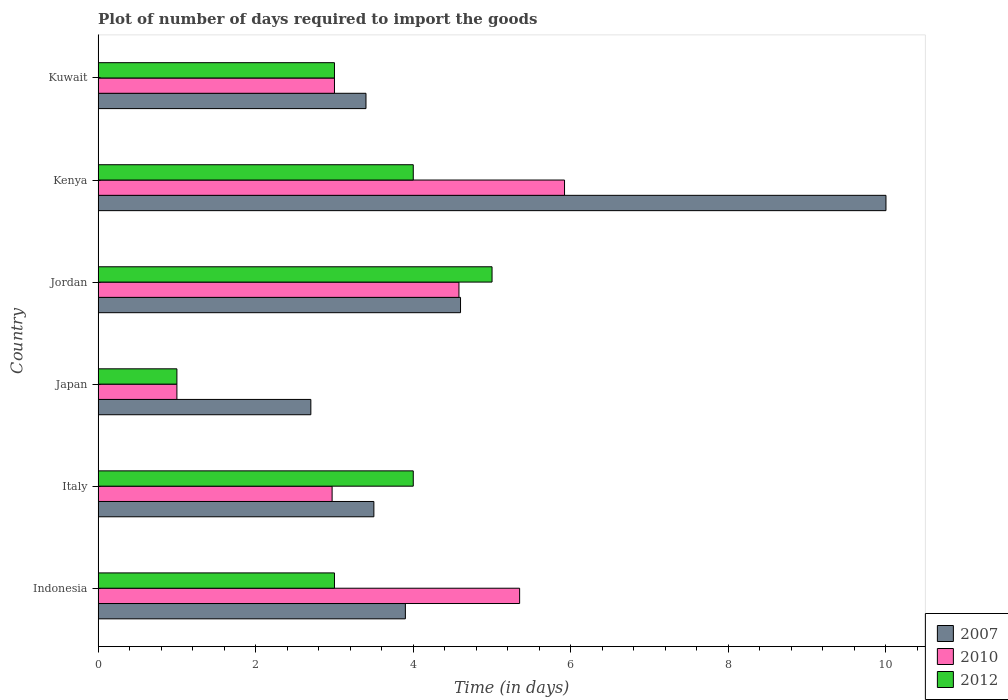Are the number of bars on each tick of the Y-axis equal?
Your answer should be compact. Yes. How many bars are there on the 1st tick from the top?
Keep it short and to the point. 3. How many bars are there on the 3rd tick from the bottom?
Provide a succinct answer. 3. In how many cases, is the number of bars for a given country not equal to the number of legend labels?
Your answer should be compact. 0. What is the time required to import goods in 2007 in Kenya?
Ensure brevity in your answer.  10. In which country was the time required to import goods in 2007 maximum?
Provide a succinct answer. Kenya. What is the total time required to import goods in 2010 in the graph?
Provide a succinct answer. 22.82. What is the difference between the time required to import goods in 2010 in Japan and that in Jordan?
Provide a succinct answer. -3.58. What is the difference between the time required to import goods in 2012 in Jordan and the time required to import goods in 2010 in Kuwait?
Make the answer very short. 2. What is the average time required to import goods in 2012 per country?
Provide a succinct answer. 3.33. What is the difference between the time required to import goods in 2010 and time required to import goods in 2007 in Jordan?
Offer a terse response. -0.02. In how many countries, is the time required to import goods in 2010 greater than 1.6 days?
Your answer should be very brief. 5. What is the ratio of the time required to import goods in 2007 in Indonesia to that in Japan?
Give a very brief answer. 1.44. Is the difference between the time required to import goods in 2010 in Italy and Jordan greater than the difference between the time required to import goods in 2007 in Italy and Jordan?
Ensure brevity in your answer.  No. What is the difference between the highest and the second highest time required to import goods in 2010?
Make the answer very short. 0.57. What is the difference between the highest and the lowest time required to import goods in 2010?
Keep it short and to the point. 4.92. Is the sum of the time required to import goods in 2010 in Italy and Kenya greater than the maximum time required to import goods in 2012 across all countries?
Keep it short and to the point. Yes. Is it the case that in every country, the sum of the time required to import goods in 2010 and time required to import goods in 2007 is greater than the time required to import goods in 2012?
Provide a short and direct response. Yes. How many bars are there?
Your answer should be compact. 18. Are all the bars in the graph horizontal?
Provide a short and direct response. Yes. How are the legend labels stacked?
Make the answer very short. Vertical. What is the title of the graph?
Provide a short and direct response. Plot of number of days required to import the goods. Does "1993" appear as one of the legend labels in the graph?
Provide a short and direct response. No. What is the label or title of the X-axis?
Your response must be concise. Time (in days). What is the label or title of the Y-axis?
Provide a short and direct response. Country. What is the Time (in days) in 2007 in Indonesia?
Your answer should be very brief. 3.9. What is the Time (in days) of 2010 in Indonesia?
Your answer should be compact. 5.35. What is the Time (in days) in 2012 in Indonesia?
Your answer should be compact. 3. What is the Time (in days) of 2007 in Italy?
Offer a terse response. 3.5. What is the Time (in days) of 2010 in Italy?
Your response must be concise. 2.97. What is the Time (in days) of 2007 in Japan?
Your answer should be very brief. 2.7. What is the Time (in days) of 2012 in Japan?
Offer a very short reply. 1. What is the Time (in days) of 2010 in Jordan?
Your answer should be very brief. 4.58. What is the Time (in days) of 2012 in Jordan?
Provide a succinct answer. 5. What is the Time (in days) of 2010 in Kenya?
Provide a short and direct response. 5.92. What is the Time (in days) in 2012 in Kenya?
Provide a succinct answer. 4. What is the Time (in days) in 2007 in Kuwait?
Make the answer very short. 3.4. What is the Time (in days) in 2010 in Kuwait?
Provide a succinct answer. 3. What is the Time (in days) in 2012 in Kuwait?
Offer a very short reply. 3. Across all countries, what is the maximum Time (in days) in 2007?
Offer a terse response. 10. Across all countries, what is the maximum Time (in days) in 2010?
Provide a short and direct response. 5.92. Across all countries, what is the minimum Time (in days) of 2007?
Your response must be concise. 2.7. Across all countries, what is the minimum Time (in days) in 2012?
Give a very brief answer. 1. What is the total Time (in days) of 2007 in the graph?
Offer a terse response. 28.1. What is the total Time (in days) in 2010 in the graph?
Provide a short and direct response. 22.82. What is the total Time (in days) of 2012 in the graph?
Your response must be concise. 20. What is the difference between the Time (in days) in 2010 in Indonesia and that in Italy?
Your response must be concise. 2.38. What is the difference between the Time (in days) in 2012 in Indonesia and that in Italy?
Provide a succinct answer. -1. What is the difference between the Time (in days) of 2010 in Indonesia and that in Japan?
Your answer should be very brief. 4.35. What is the difference between the Time (in days) in 2012 in Indonesia and that in Japan?
Provide a succinct answer. 2. What is the difference between the Time (in days) of 2010 in Indonesia and that in Jordan?
Your answer should be compact. 0.77. What is the difference between the Time (in days) in 2007 in Indonesia and that in Kenya?
Your response must be concise. -6.1. What is the difference between the Time (in days) in 2010 in Indonesia and that in Kenya?
Ensure brevity in your answer.  -0.57. What is the difference between the Time (in days) of 2007 in Indonesia and that in Kuwait?
Ensure brevity in your answer.  0.5. What is the difference between the Time (in days) in 2010 in Indonesia and that in Kuwait?
Make the answer very short. 2.35. What is the difference between the Time (in days) in 2012 in Indonesia and that in Kuwait?
Ensure brevity in your answer.  0. What is the difference between the Time (in days) in 2010 in Italy and that in Japan?
Your response must be concise. 1.97. What is the difference between the Time (in days) in 2012 in Italy and that in Japan?
Your response must be concise. 3. What is the difference between the Time (in days) of 2010 in Italy and that in Jordan?
Your answer should be very brief. -1.61. What is the difference between the Time (in days) in 2012 in Italy and that in Jordan?
Your answer should be compact. -1. What is the difference between the Time (in days) of 2007 in Italy and that in Kenya?
Make the answer very short. -6.5. What is the difference between the Time (in days) of 2010 in Italy and that in Kenya?
Offer a terse response. -2.95. What is the difference between the Time (in days) in 2012 in Italy and that in Kenya?
Give a very brief answer. 0. What is the difference between the Time (in days) of 2007 in Italy and that in Kuwait?
Provide a short and direct response. 0.1. What is the difference between the Time (in days) in 2010 in Italy and that in Kuwait?
Your response must be concise. -0.03. What is the difference between the Time (in days) in 2007 in Japan and that in Jordan?
Keep it short and to the point. -1.9. What is the difference between the Time (in days) of 2010 in Japan and that in Jordan?
Your answer should be compact. -3.58. What is the difference between the Time (in days) in 2012 in Japan and that in Jordan?
Your answer should be very brief. -4. What is the difference between the Time (in days) of 2010 in Japan and that in Kenya?
Your response must be concise. -4.92. What is the difference between the Time (in days) in 2012 in Japan and that in Kenya?
Provide a succinct answer. -3. What is the difference between the Time (in days) in 2007 in Japan and that in Kuwait?
Ensure brevity in your answer.  -0.7. What is the difference between the Time (in days) in 2007 in Jordan and that in Kenya?
Your answer should be very brief. -5.4. What is the difference between the Time (in days) in 2010 in Jordan and that in Kenya?
Offer a terse response. -1.34. What is the difference between the Time (in days) of 2012 in Jordan and that in Kenya?
Offer a terse response. 1. What is the difference between the Time (in days) of 2007 in Jordan and that in Kuwait?
Provide a short and direct response. 1.2. What is the difference between the Time (in days) in 2010 in Jordan and that in Kuwait?
Provide a short and direct response. 1.58. What is the difference between the Time (in days) of 2010 in Kenya and that in Kuwait?
Your answer should be compact. 2.92. What is the difference between the Time (in days) of 2010 in Indonesia and the Time (in days) of 2012 in Italy?
Give a very brief answer. 1.35. What is the difference between the Time (in days) in 2007 in Indonesia and the Time (in days) in 2010 in Japan?
Make the answer very short. 2.9. What is the difference between the Time (in days) in 2010 in Indonesia and the Time (in days) in 2012 in Japan?
Offer a terse response. 4.35. What is the difference between the Time (in days) of 2007 in Indonesia and the Time (in days) of 2010 in Jordan?
Your response must be concise. -0.68. What is the difference between the Time (in days) of 2007 in Indonesia and the Time (in days) of 2010 in Kenya?
Ensure brevity in your answer.  -2.02. What is the difference between the Time (in days) in 2007 in Indonesia and the Time (in days) in 2012 in Kenya?
Your response must be concise. -0.1. What is the difference between the Time (in days) in 2010 in Indonesia and the Time (in days) in 2012 in Kenya?
Your answer should be very brief. 1.35. What is the difference between the Time (in days) in 2010 in Indonesia and the Time (in days) in 2012 in Kuwait?
Your answer should be compact. 2.35. What is the difference between the Time (in days) of 2007 in Italy and the Time (in days) of 2010 in Japan?
Offer a terse response. 2.5. What is the difference between the Time (in days) of 2007 in Italy and the Time (in days) of 2012 in Japan?
Provide a short and direct response. 2.5. What is the difference between the Time (in days) of 2010 in Italy and the Time (in days) of 2012 in Japan?
Provide a short and direct response. 1.97. What is the difference between the Time (in days) of 2007 in Italy and the Time (in days) of 2010 in Jordan?
Your answer should be compact. -1.08. What is the difference between the Time (in days) in 2010 in Italy and the Time (in days) in 2012 in Jordan?
Your answer should be very brief. -2.03. What is the difference between the Time (in days) in 2007 in Italy and the Time (in days) in 2010 in Kenya?
Your response must be concise. -2.42. What is the difference between the Time (in days) in 2010 in Italy and the Time (in days) in 2012 in Kenya?
Your answer should be compact. -1.03. What is the difference between the Time (in days) of 2010 in Italy and the Time (in days) of 2012 in Kuwait?
Make the answer very short. -0.03. What is the difference between the Time (in days) of 2007 in Japan and the Time (in days) of 2010 in Jordan?
Ensure brevity in your answer.  -1.88. What is the difference between the Time (in days) in 2007 in Japan and the Time (in days) in 2012 in Jordan?
Provide a short and direct response. -2.3. What is the difference between the Time (in days) of 2010 in Japan and the Time (in days) of 2012 in Jordan?
Offer a very short reply. -4. What is the difference between the Time (in days) of 2007 in Japan and the Time (in days) of 2010 in Kenya?
Your answer should be very brief. -3.22. What is the difference between the Time (in days) of 2010 in Japan and the Time (in days) of 2012 in Kenya?
Offer a very short reply. -3. What is the difference between the Time (in days) of 2007 in Japan and the Time (in days) of 2012 in Kuwait?
Ensure brevity in your answer.  -0.3. What is the difference between the Time (in days) in 2010 in Japan and the Time (in days) in 2012 in Kuwait?
Provide a succinct answer. -2. What is the difference between the Time (in days) of 2007 in Jordan and the Time (in days) of 2010 in Kenya?
Provide a succinct answer. -1.32. What is the difference between the Time (in days) of 2010 in Jordan and the Time (in days) of 2012 in Kenya?
Your answer should be very brief. 0.58. What is the difference between the Time (in days) of 2007 in Jordan and the Time (in days) of 2012 in Kuwait?
Your response must be concise. 1.6. What is the difference between the Time (in days) in 2010 in Jordan and the Time (in days) in 2012 in Kuwait?
Keep it short and to the point. 1.58. What is the difference between the Time (in days) in 2007 in Kenya and the Time (in days) in 2010 in Kuwait?
Make the answer very short. 7. What is the difference between the Time (in days) in 2007 in Kenya and the Time (in days) in 2012 in Kuwait?
Provide a short and direct response. 7. What is the difference between the Time (in days) in 2010 in Kenya and the Time (in days) in 2012 in Kuwait?
Give a very brief answer. 2.92. What is the average Time (in days) of 2007 per country?
Make the answer very short. 4.68. What is the average Time (in days) in 2010 per country?
Offer a terse response. 3.8. What is the average Time (in days) in 2012 per country?
Give a very brief answer. 3.33. What is the difference between the Time (in days) in 2007 and Time (in days) in 2010 in Indonesia?
Keep it short and to the point. -1.45. What is the difference between the Time (in days) of 2007 and Time (in days) of 2012 in Indonesia?
Ensure brevity in your answer.  0.9. What is the difference between the Time (in days) in 2010 and Time (in days) in 2012 in Indonesia?
Provide a succinct answer. 2.35. What is the difference between the Time (in days) in 2007 and Time (in days) in 2010 in Italy?
Give a very brief answer. 0.53. What is the difference between the Time (in days) of 2010 and Time (in days) of 2012 in Italy?
Your answer should be very brief. -1.03. What is the difference between the Time (in days) of 2010 and Time (in days) of 2012 in Japan?
Provide a succinct answer. 0. What is the difference between the Time (in days) of 2007 and Time (in days) of 2010 in Jordan?
Offer a terse response. 0.02. What is the difference between the Time (in days) of 2007 and Time (in days) of 2012 in Jordan?
Provide a short and direct response. -0.4. What is the difference between the Time (in days) of 2010 and Time (in days) of 2012 in Jordan?
Offer a terse response. -0.42. What is the difference between the Time (in days) in 2007 and Time (in days) in 2010 in Kenya?
Provide a succinct answer. 4.08. What is the difference between the Time (in days) in 2007 and Time (in days) in 2012 in Kenya?
Your response must be concise. 6. What is the difference between the Time (in days) in 2010 and Time (in days) in 2012 in Kenya?
Provide a short and direct response. 1.92. What is the ratio of the Time (in days) in 2007 in Indonesia to that in Italy?
Provide a succinct answer. 1.11. What is the ratio of the Time (in days) in 2010 in Indonesia to that in Italy?
Your answer should be very brief. 1.8. What is the ratio of the Time (in days) of 2012 in Indonesia to that in Italy?
Ensure brevity in your answer.  0.75. What is the ratio of the Time (in days) of 2007 in Indonesia to that in Japan?
Offer a very short reply. 1.44. What is the ratio of the Time (in days) in 2010 in Indonesia to that in Japan?
Offer a terse response. 5.35. What is the ratio of the Time (in days) of 2007 in Indonesia to that in Jordan?
Your response must be concise. 0.85. What is the ratio of the Time (in days) in 2010 in Indonesia to that in Jordan?
Give a very brief answer. 1.17. What is the ratio of the Time (in days) of 2012 in Indonesia to that in Jordan?
Offer a very short reply. 0.6. What is the ratio of the Time (in days) of 2007 in Indonesia to that in Kenya?
Your response must be concise. 0.39. What is the ratio of the Time (in days) of 2010 in Indonesia to that in Kenya?
Give a very brief answer. 0.9. What is the ratio of the Time (in days) of 2007 in Indonesia to that in Kuwait?
Give a very brief answer. 1.15. What is the ratio of the Time (in days) of 2010 in Indonesia to that in Kuwait?
Ensure brevity in your answer.  1.78. What is the ratio of the Time (in days) of 2012 in Indonesia to that in Kuwait?
Give a very brief answer. 1. What is the ratio of the Time (in days) in 2007 in Italy to that in Japan?
Offer a terse response. 1.3. What is the ratio of the Time (in days) of 2010 in Italy to that in Japan?
Provide a succinct answer. 2.97. What is the ratio of the Time (in days) of 2007 in Italy to that in Jordan?
Keep it short and to the point. 0.76. What is the ratio of the Time (in days) of 2010 in Italy to that in Jordan?
Your answer should be very brief. 0.65. What is the ratio of the Time (in days) in 2012 in Italy to that in Jordan?
Keep it short and to the point. 0.8. What is the ratio of the Time (in days) in 2010 in Italy to that in Kenya?
Provide a short and direct response. 0.5. What is the ratio of the Time (in days) in 2007 in Italy to that in Kuwait?
Ensure brevity in your answer.  1.03. What is the ratio of the Time (in days) in 2010 in Italy to that in Kuwait?
Your answer should be compact. 0.99. What is the ratio of the Time (in days) of 2007 in Japan to that in Jordan?
Ensure brevity in your answer.  0.59. What is the ratio of the Time (in days) in 2010 in Japan to that in Jordan?
Provide a short and direct response. 0.22. What is the ratio of the Time (in days) in 2007 in Japan to that in Kenya?
Your answer should be very brief. 0.27. What is the ratio of the Time (in days) of 2010 in Japan to that in Kenya?
Your response must be concise. 0.17. What is the ratio of the Time (in days) in 2012 in Japan to that in Kenya?
Ensure brevity in your answer.  0.25. What is the ratio of the Time (in days) in 2007 in Japan to that in Kuwait?
Provide a succinct answer. 0.79. What is the ratio of the Time (in days) in 2010 in Japan to that in Kuwait?
Keep it short and to the point. 0.33. What is the ratio of the Time (in days) in 2012 in Japan to that in Kuwait?
Your answer should be very brief. 0.33. What is the ratio of the Time (in days) in 2007 in Jordan to that in Kenya?
Make the answer very short. 0.46. What is the ratio of the Time (in days) of 2010 in Jordan to that in Kenya?
Your response must be concise. 0.77. What is the ratio of the Time (in days) in 2012 in Jordan to that in Kenya?
Offer a terse response. 1.25. What is the ratio of the Time (in days) in 2007 in Jordan to that in Kuwait?
Keep it short and to the point. 1.35. What is the ratio of the Time (in days) of 2010 in Jordan to that in Kuwait?
Offer a terse response. 1.53. What is the ratio of the Time (in days) of 2007 in Kenya to that in Kuwait?
Ensure brevity in your answer.  2.94. What is the ratio of the Time (in days) in 2010 in Kenya to that in Kuwait?
Provide a short and direct response. 1.97. What is the difference between the highest and the second highest Time (in days) in 2010?
Make the answer very short. 0.57. What is the difference between the highest and the second highest Time (in days) of 2012?
Your response must be concise. 1. What is the difference between the highest and the lowest Time (in days) of 2010?
Your answer should be compact. 4.92. 